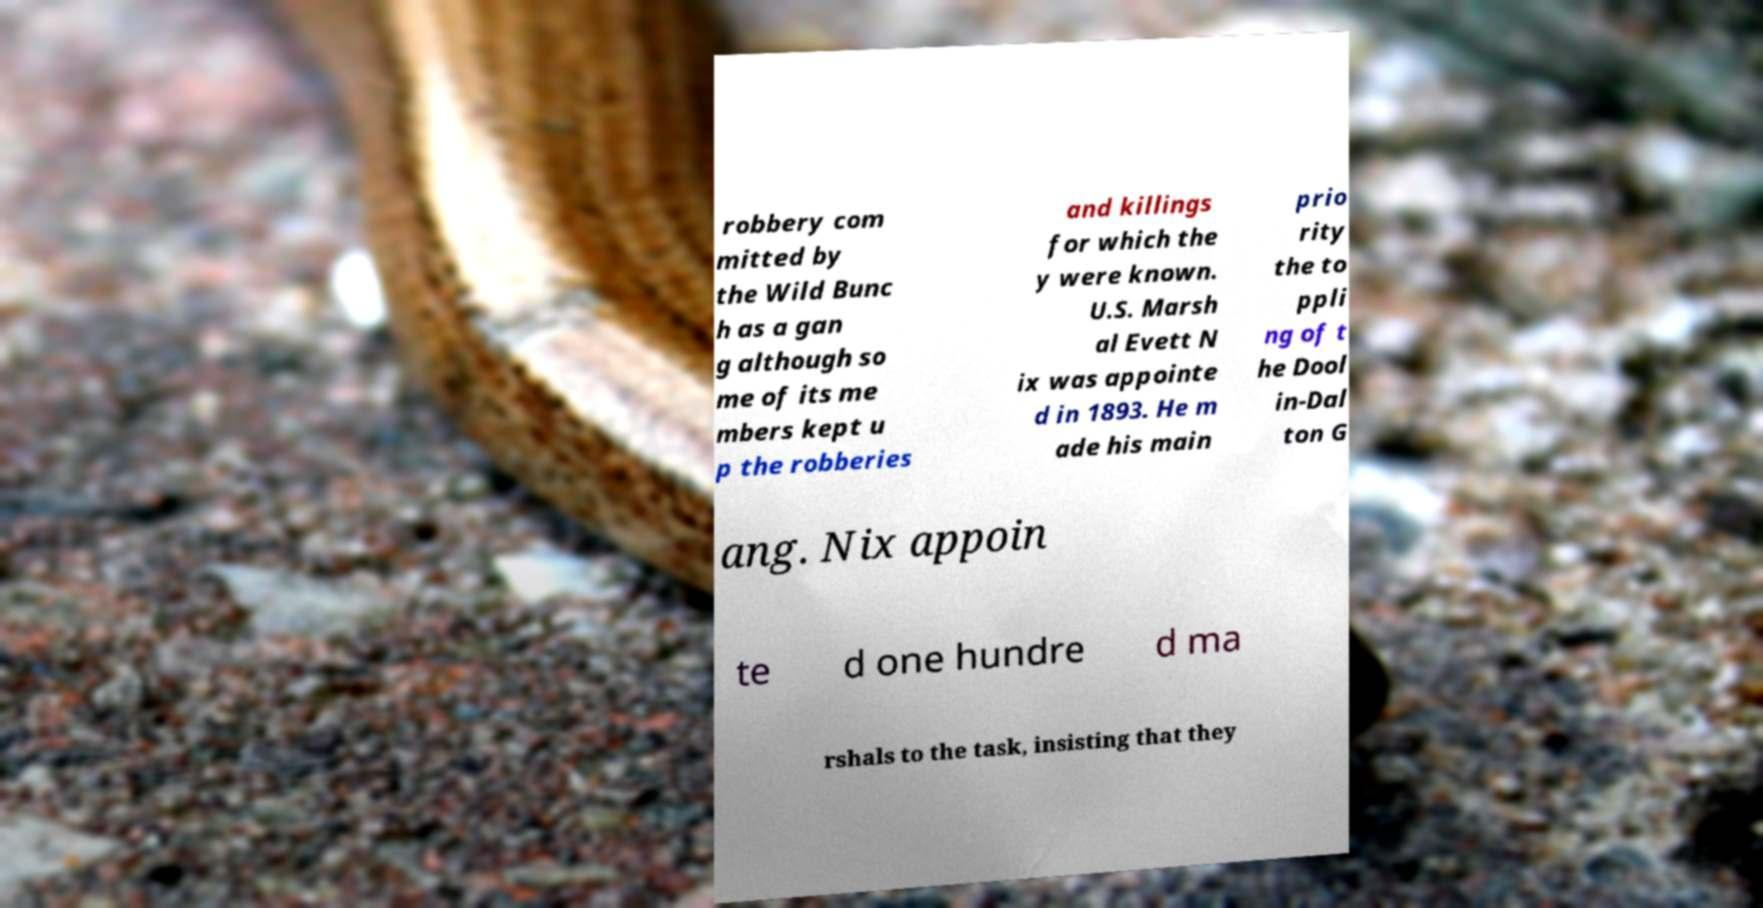There's text embedded in this image that I need extracted. Can you transcribe it verbatim? robbery com mitted by the Wild Bunc h as a gan g although so me of its me mbers kept u p the robberies and killings for which the y were known. U.S. Marsh al Evett N ix was appointe d in 1893. He m ade his main prio rity the to ppli ng of t he Dool in-Dal ton G ang. Nix appoin te d one hundre d ma rshals to the task, insisting that they 